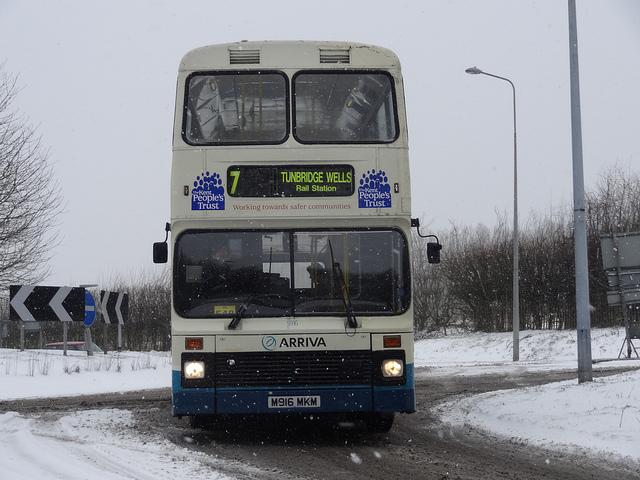Does the road look dangerous?
Concise answer only. Yes. What season of the year is it?
Quick response, please. Winter. What number of stories is this bus?
Write a very short answer. 2. 